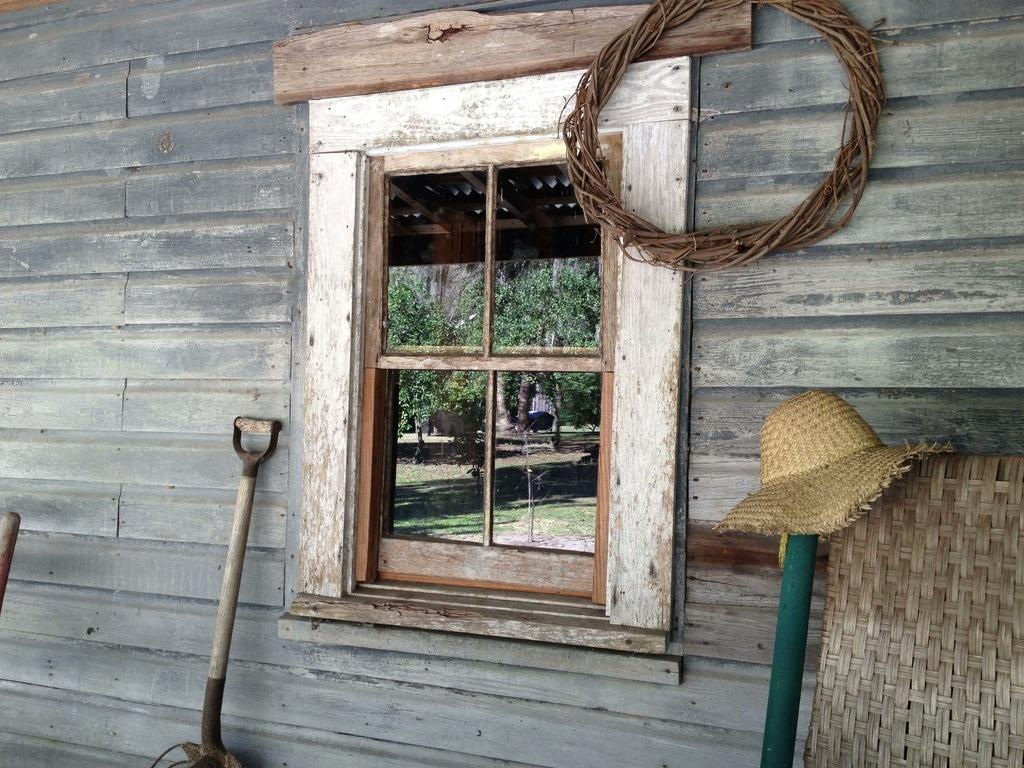What is one of the objects in the image? There is a hat in the image. What can be seen on one of the objects? There is a glass window on one of the objects. What is visible through the glass window? Grass and trees are visible through the glass window. What is the background of the image? Trees are visible in the background through the glass window. What type of gold object is visible in the image? There is no gold object present in the image. 